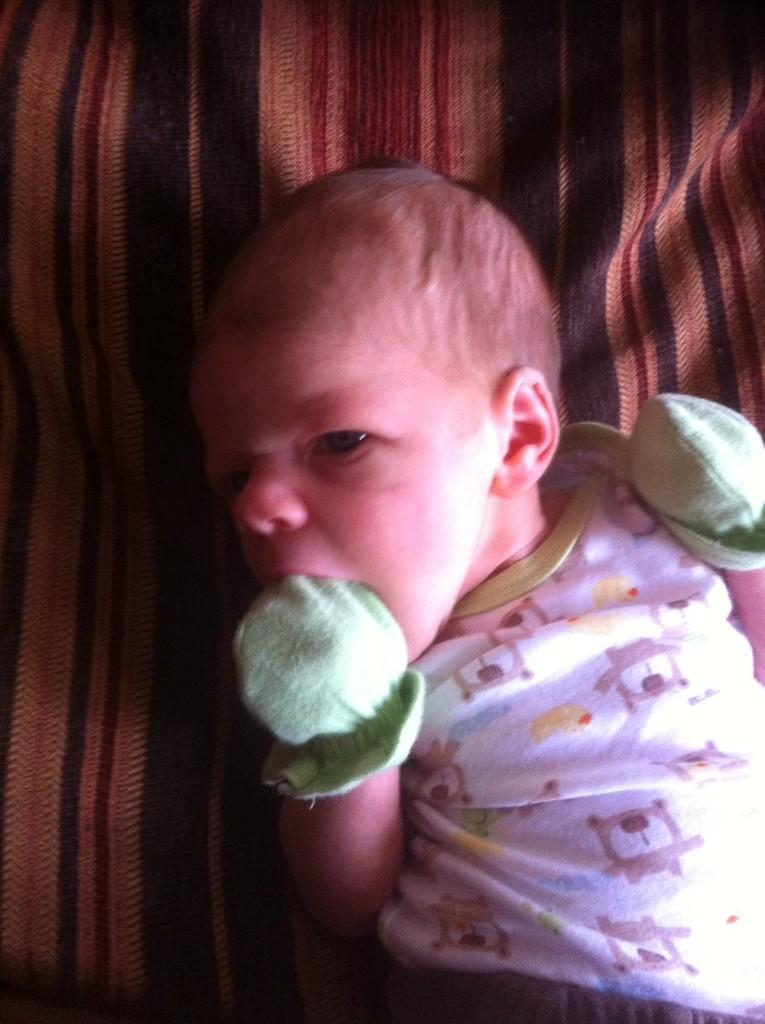What is the main subject of the image? The main subject of the image is a baby. What is the baby's position in the image? The baby is lying down. What clothing item is the baby wearing? The baby is wearing gloves. What type of prison can be seen in the background of the image? There is no prison present in the image; it features a baby lying down and wearing gloves. How does the baby cover its territory in the image? The baby is not shown covering any territory in the image; it is simply lying down and wearing gloves. 